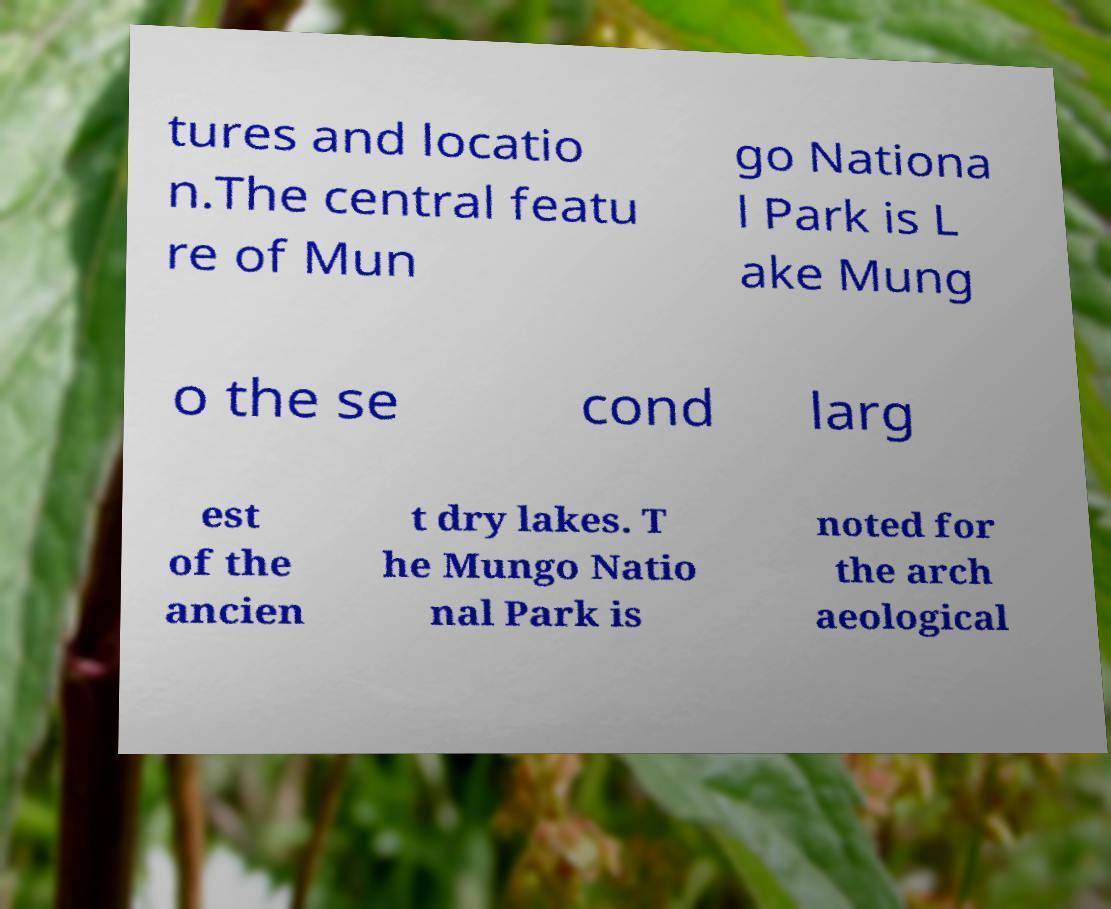For documentation purposes, I need the text within this image transcribed. Could you provide that? tures and locatio n.The central featu re of Mun go Nationa l Park is L ake Mung o the se cond larg est of the ancien t dry lakes. T he Mungo Natio nal Park is noted for the arch aeological 